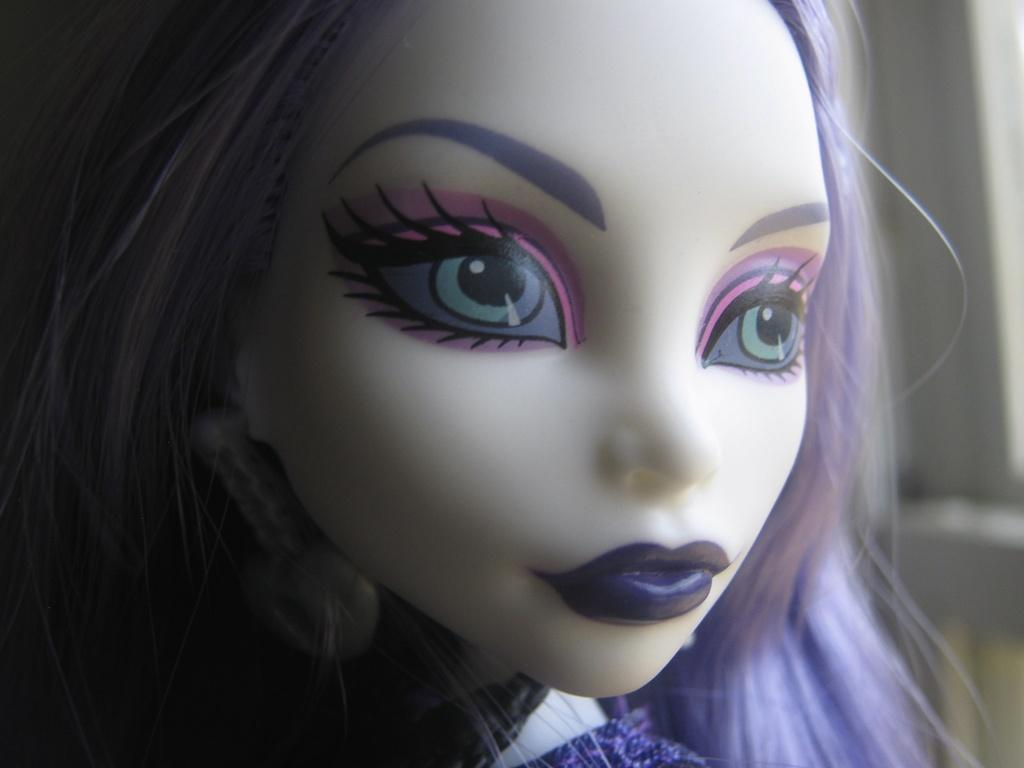What is the main subject in the foreground of the image? There is a doll in the foreground of the image. Can you describe the background of the image? The background of the image is blurry. What type of salt can be seen on the doll's head in the image? There is no salt present on the doll's head in the image. What kind of pump is visible in the background of the image? There is no pump visible in the image; the background is blurry. 